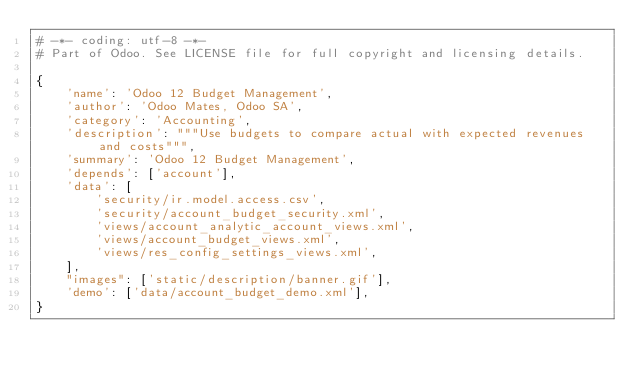Convert code to text. <code><loc_0><loc_0><loc_500><loc_500><_Python_># -*- coding: utf-8 -*-
# Part of Odoo. See LICENSE file for full copyright and licensing details.

{
    'name': 'Odoo 12 Budget Management',
    'author': 'Odoo Mates, Odoo SA',
    'category': 'Accounting',
    'description': """Use budgets to compare actual with expected revenues and costs""",
    'summary': 'Odoo 12 Budget Management',
    'depends': ['account'],
    'data': [
        'security/ir.model.access.csv',
        'security/account_budget_security.xml',
        'views/account_analytic_account_views.xml',
        'views/account_budget_views.xml',
        'views/res_config_settings_views.xml',
    ],
    "images": ['static/description/banner.gif'],
    'demo': ['data/account_budget_demo.xml'],
}
</code> 